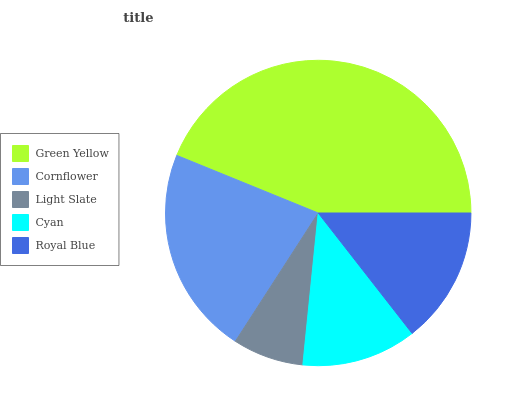Is Light Slate the minimum?
Answer yes or no. Yes. Is Green Yellow the maximum?
Answer yes or no. Yes. Is Cornflower the minimum?
Answer yes or no. No. Is Cornflower the maximum?
Answer yes or no. No. Is Green Yellow greater than Cornflower?
Answer yes or no. Yes. Is Cornflower less than Green Yellow?
Answer yes or no. Yes. Is Cornflower greater than Green Yellow?
Answer yes or no. No. Is Green Yellow less than Cornflower?
Answer yes or no. No. Is Royal Blue the high median?
Answer yes or no. Yes. Is Royal Blue the low median?
Answer yes or no. Yes. Is Cyan the high median?
Answer yes or no. No. Is Light Slate the low median?
Answer yes or no. No. 